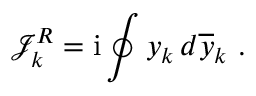Convert formula to latex. <formula><loc_0><loc_0><loc_500><loc_500>\mathcal { J } _ { k } ^ { R } = i \oint y _ { k } \, d \overline { y } _ { k } \ .</formula> 